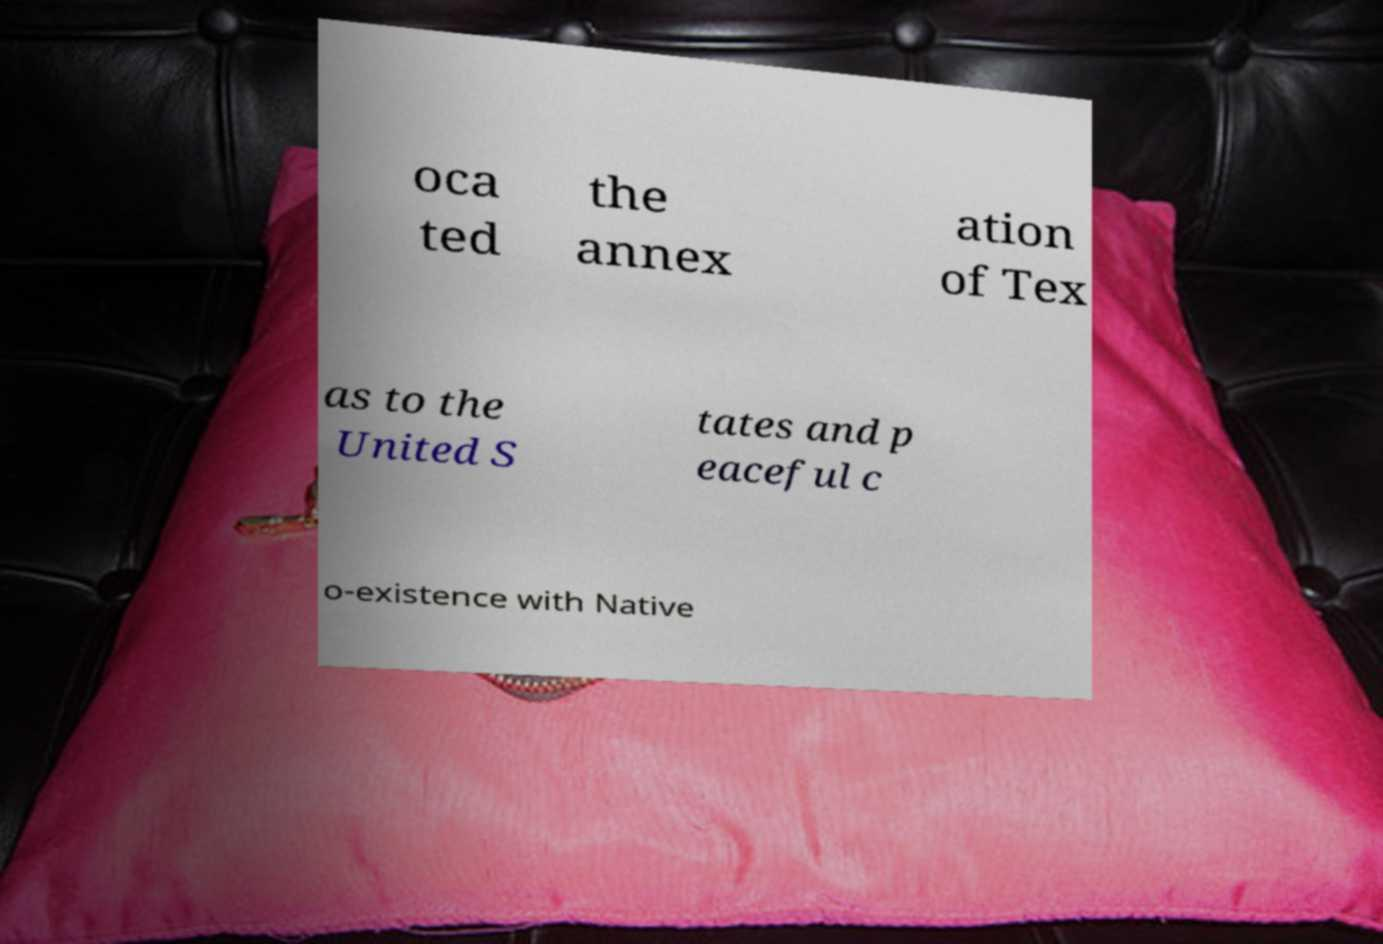Could you extract and type out the text from this image? oca ted the annex ation of Tex as to the United S tates and p eaceful c o-existence with Native 